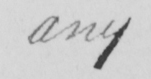Can you tell me what this handwritten text says? any 